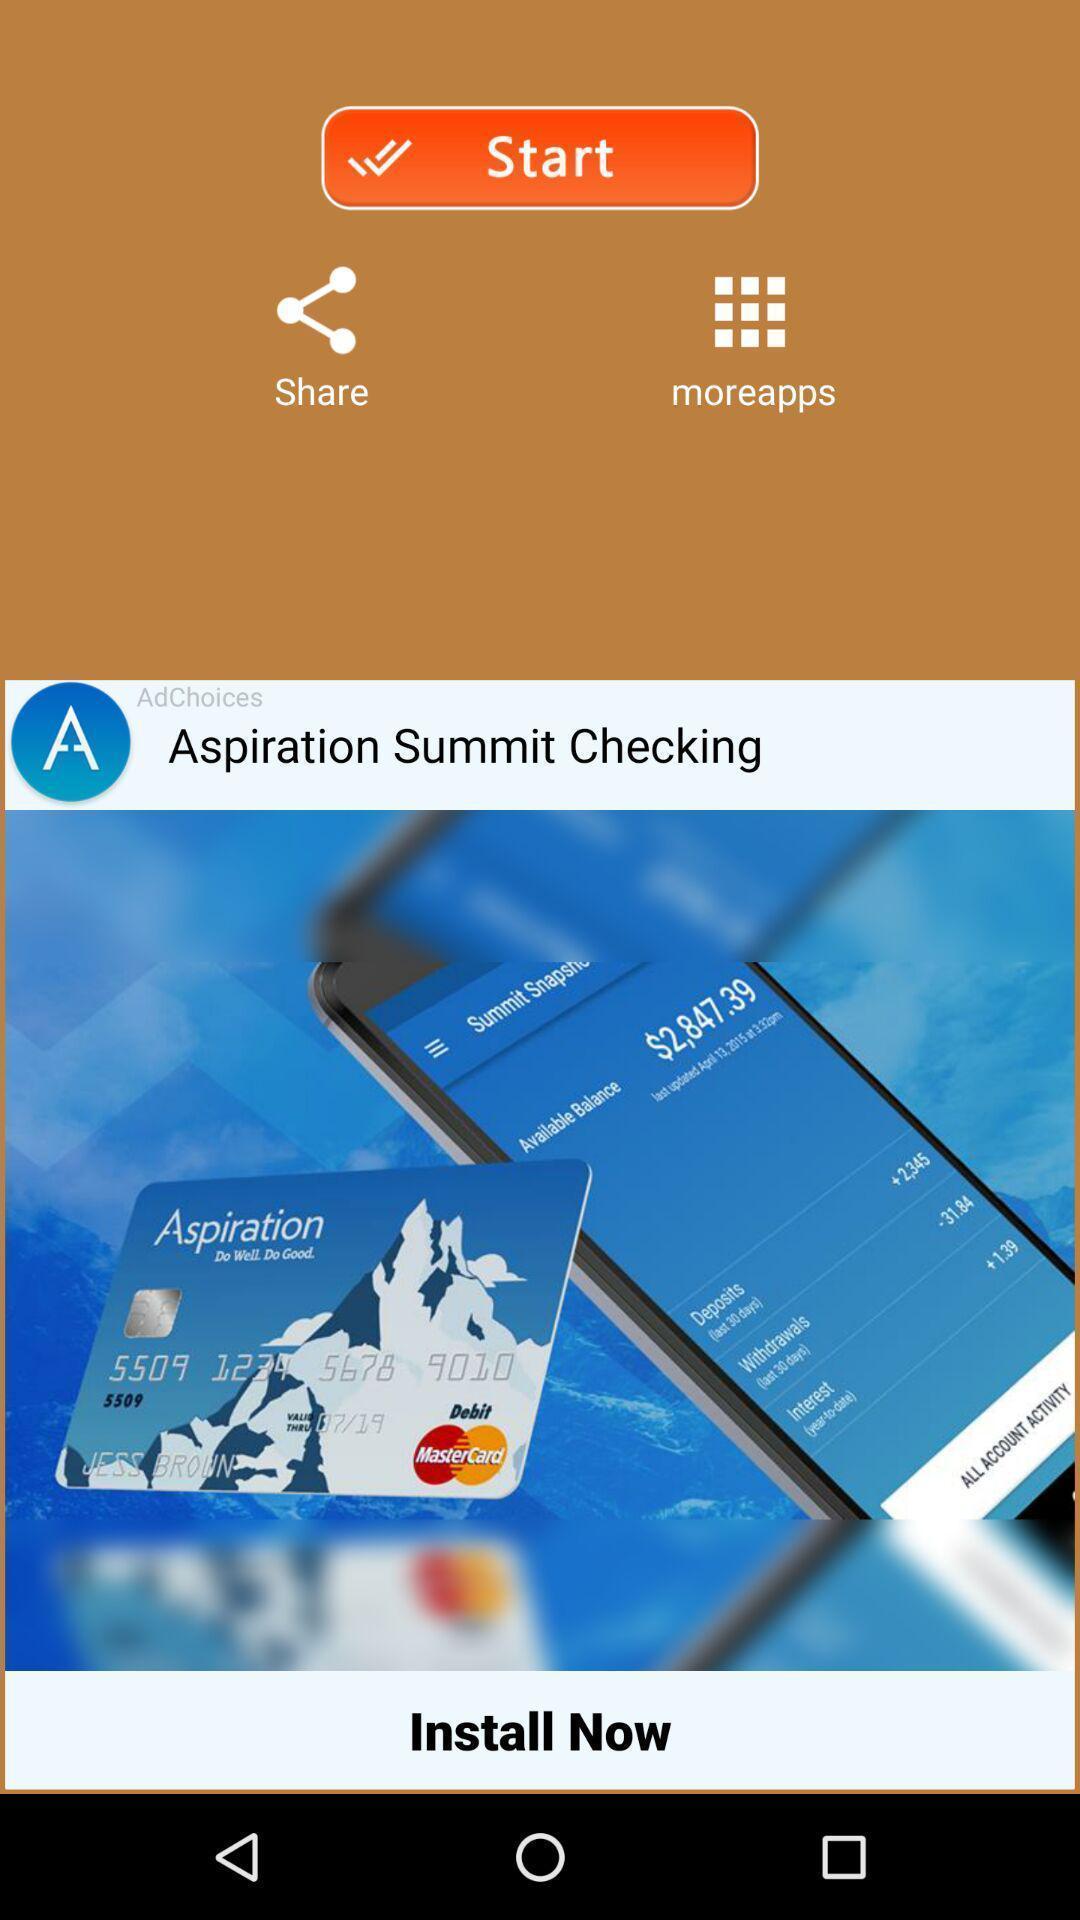Describe the content in this image. Welcome page of a financial application. 